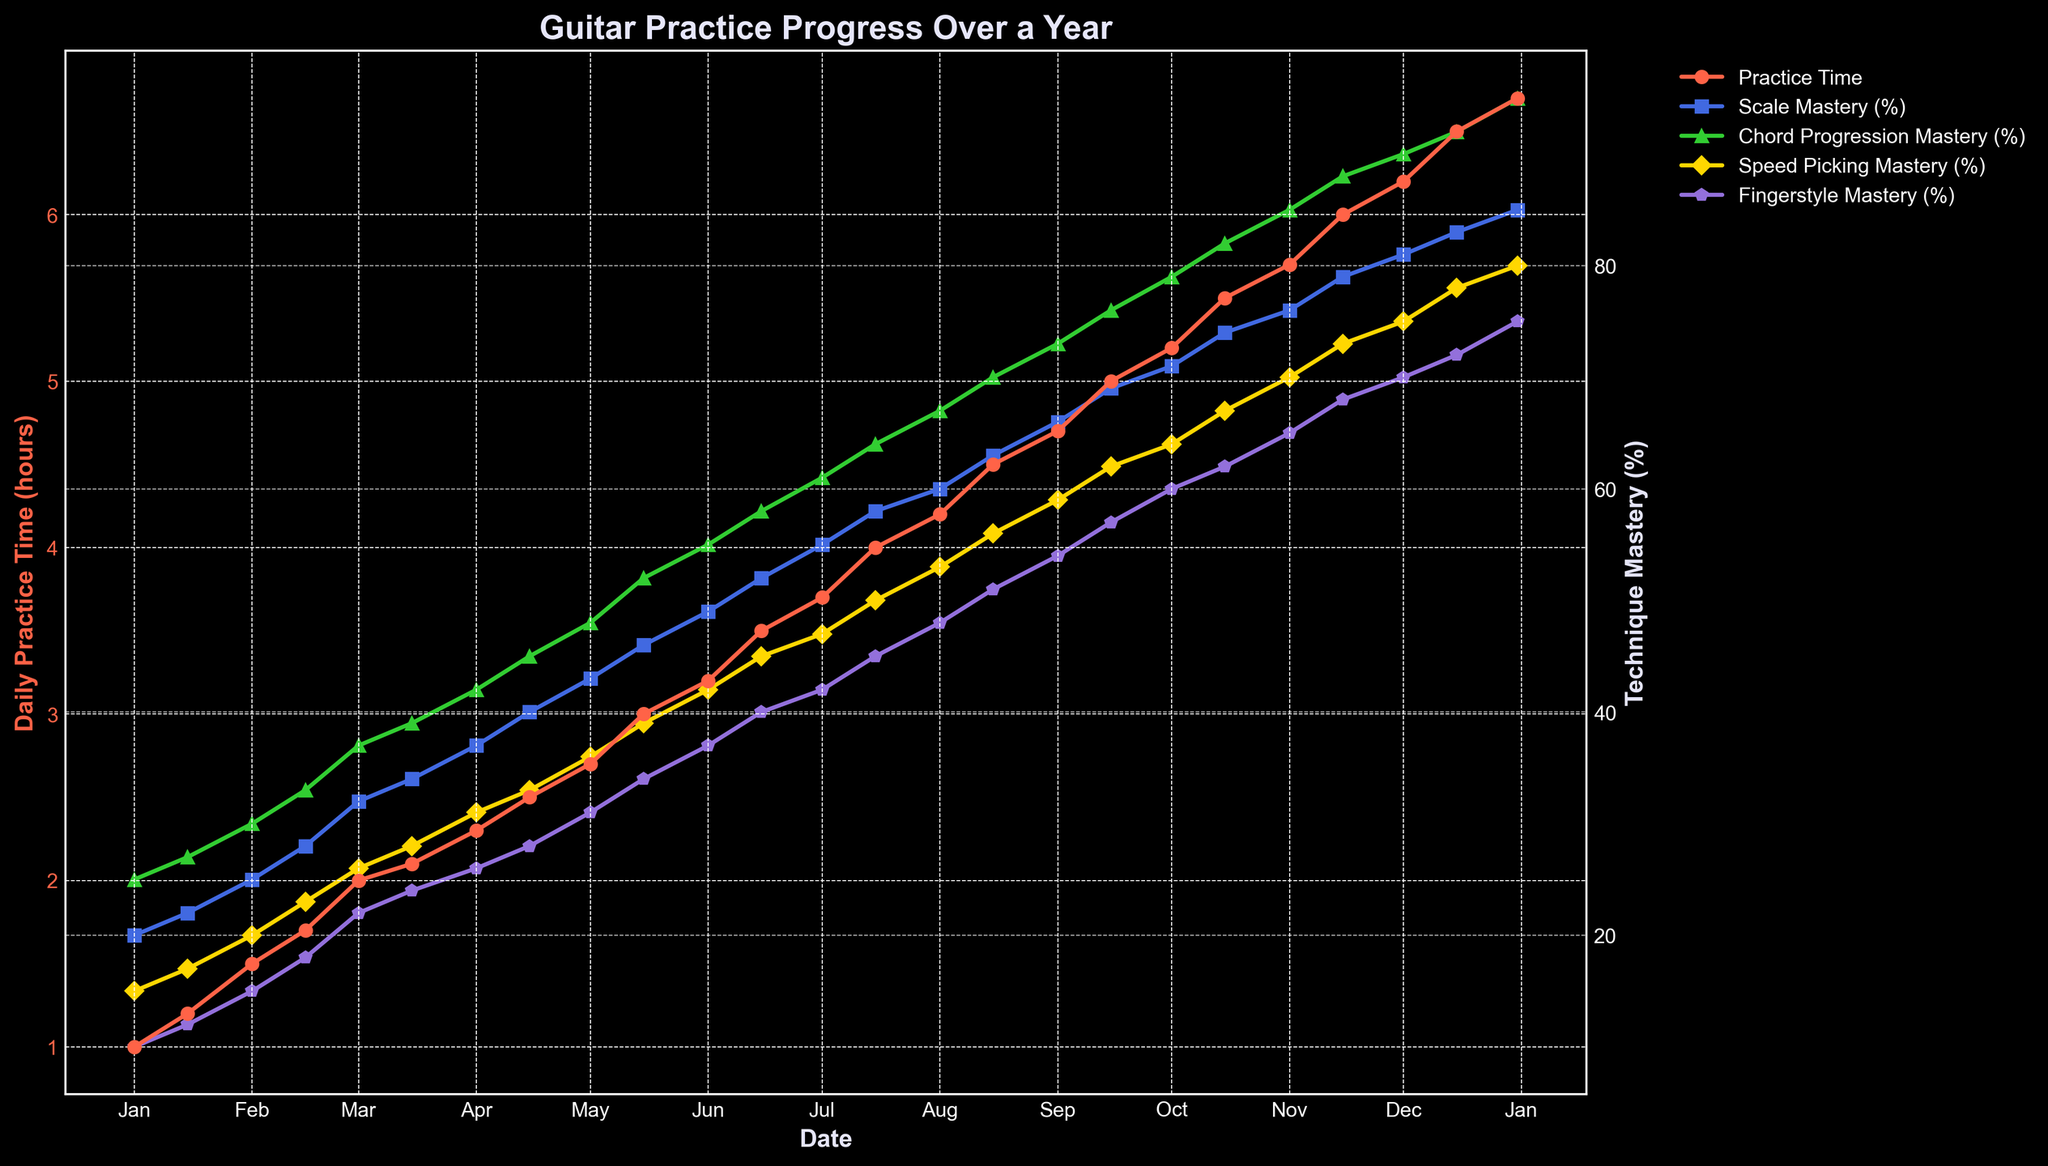What's the title of the plot? The title of the plot is shown at the top and is called "Guitar Practice Progress Over a Year".
Answer: Guitar Practice Progress Over a Year What are the colors used for different technique masteries? The plot uses different colors for each technique: Scale Mastery (%) in blue, Chord Progression Mastery (%) in green, Speed Picking Mastery (%) in yellow, and Fingerstyle Mastery (%) in purple.
Answer: Blue, Green, Yellow, Purple How many data points are used to represent the Daily Practice Time (hours)? By counting the markers on the Daily Practice Time (hours) line, we can see there are 24 data points, one for each date entry throughout the year.
Answer: 24 Which technique had the highest mastery percentage by the end of the year? At the end of the year (Dec 31), the plot shows that Chord Progression Mastery (%) had the highest value, reaching 95%.
Answer: Chord Progression Mastery What is the difference in Daily Practice Time between January 1st and December 31st? The Daily Practice Time on January 1st is 1.0 hours and on December 31st is 6.7 hours. The difference is 6.7 - 1.0 = 5.7 hours.
Answer: 5.7 hours On which date did Fingerstyle Mastery (%) first reach or exceed 40%? Observing the Fingerstyle Mastery (%) line, it first reaches 40% on June 15th.
Answer: June 15 What is the average Scale Mastery (%) of the entire year? The average Scale Mastery (%) is calculated by summing all the monthly values and dividing by 24. The sum is 1528, so the average is 1528 / 24 ≈ 63.67.
Answer: 63.67 How does the rate of increase in Chord Progression Mastery (%) compare to Scale Mastery (%) by the end of the year? Comparing both lines from beginning to end: Scale Mastery increased from 20% to 85% (shift of 65%), while Chord Progression Mastery increased from 25% to 95% (shift of 70%).
Answer: Higher for Chord Progression At what point did Daily Practice Time (hours) start increasing more rapidly? The plot shows a noticeable increase in the slope of the Daily Practice Time line around March 1st, indicating a faster increase in practice time.
Answer: March 1 Which technique showed the most gradual improvement over the year? By examining the slopes of each line, Fingerstyle Mastery (%) has the most gradual slope increase, showing a steady and consistent improvement.
Answer: Fingerstyle Mastery 